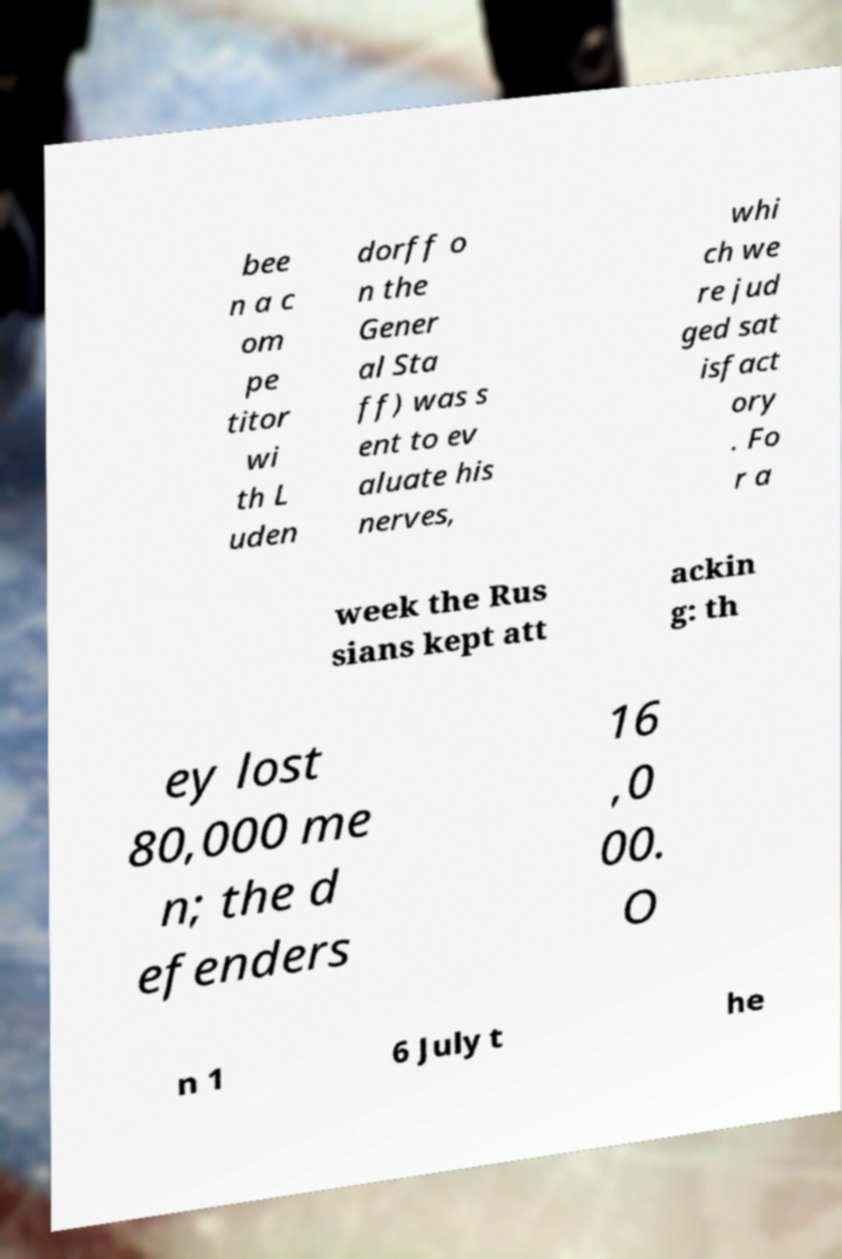Can you read and provide the text displayed in the image?This photo seems to have some interesting text. Can you extract and type it out for me? bee n a c om pe titor wi th L uden dorff o n the Gener al Sta ff) was s ent to ev aluate his nerves, whi ch we re jud ged sat isfact ory . Fo r a week the Rus sians kept att ackin g: th ey lost 80,000 me n; the d efenders 16 ,0 00. O n 1 6 July t he 